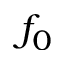<formula> <loc_0><loc_0><loc_500><loc_500>f _ { 0 }</formula> 